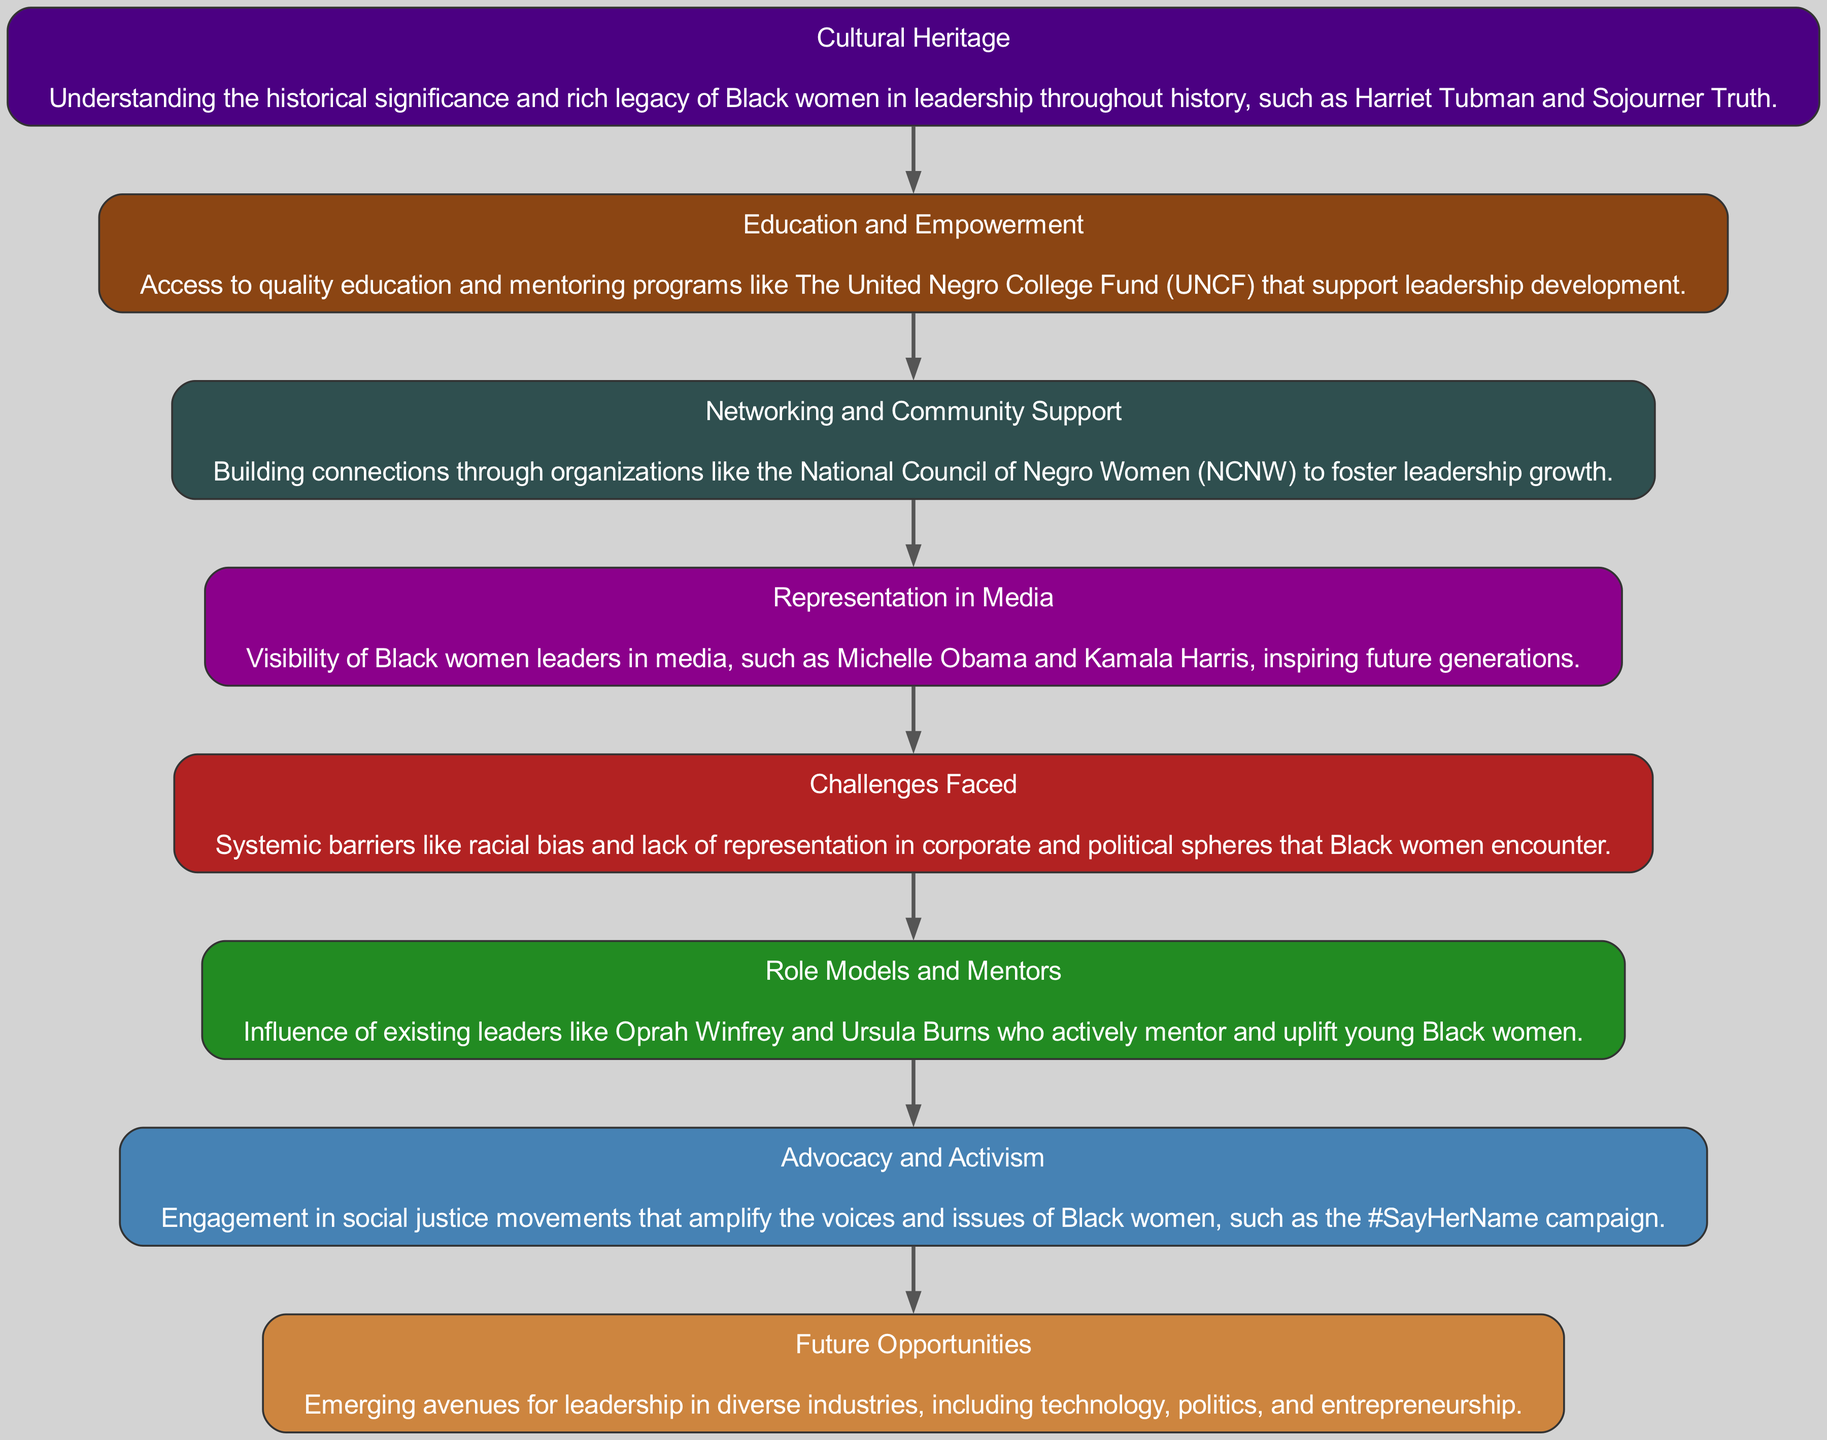What is the first node in the diagram? The first node listed in the diagram is "Cultural Heritage", which is the starting point showcasing the importance of understanding the historical significance of Black women in leadership.
Answer: Cultural Heritage How many edges are there in total? By counting the connections (edges) between the nodes in the diagram, we observe that there are seven distinct edges that connect the eight nodes.
Answer: Seven Which node represents future potential leadership avenues? The node titled "Future Opportunities" illustrates emerging avenues for leadership, indicating that there are new fields where Black women can lead.
Answer: Future Opportunities What is the relationship between "Challenges Faced" and "Advocacy and Activism"? "Challenges Faced" flows into "Role Models and Mentors", which then connects to "Advocacy and Activism", indicating that understanding challenges leads to activism efforts that support Black women.
Answer: A flow from challenges to activism What is the color associated with the "Education and Empowerment" node? The node "Education and Empowerment" is represented in SaddleBrown according to the color coding in the diagram.
Answer: SaddleBrown How many nodes represent support networks? The nodes "Education and Empowerment", "Networking and Community Support", and "Role Models and Mentors" represent aspects of support networks, totaling three nodes focused on this theme.
Answer: Three What does the "Representation in Media" node inspire? The "Representation in Media" node emphasizes the inspiration it generates for future generations of Black women leaders, showcasing the importance of visibility.
Answer: Future generations Which node emphasizes systemic barriers? The node "Challenges Faced" specifically highlights the systemic barriers such as racial bias that hinder Black women's advancement in leadership roles.
Answer: Challenges Faced 